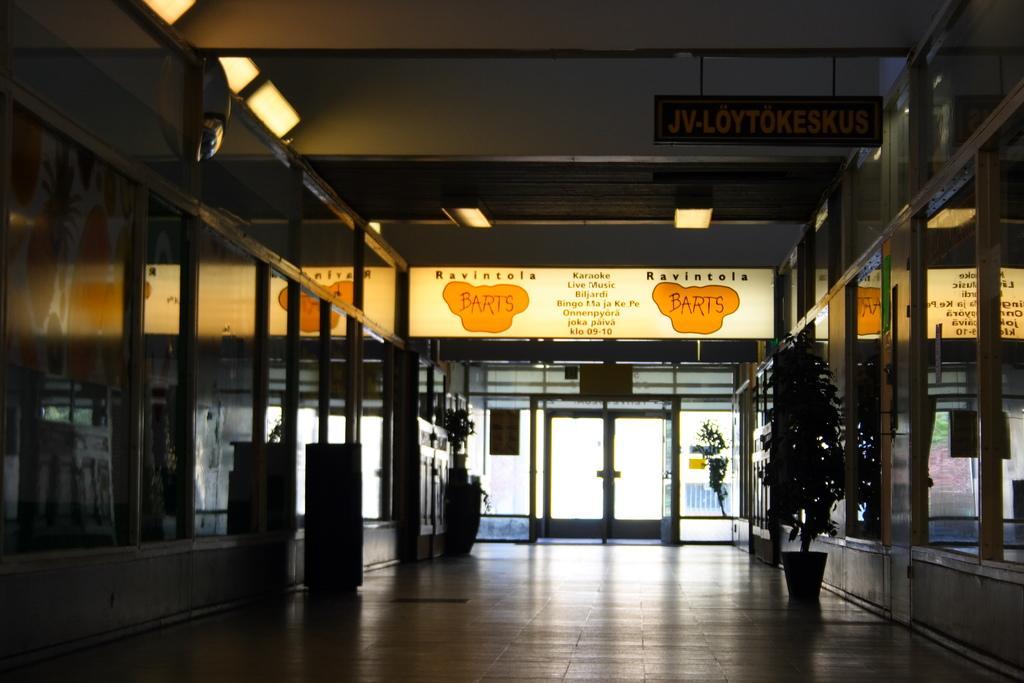Describe this image in one or two sentences. In this image I can see the dark picture in which I can see the interior of the building. I can see few boards, few lights, the ceiling, the path and few glass walls on both sides of the path. In the background I can see the glass door. 